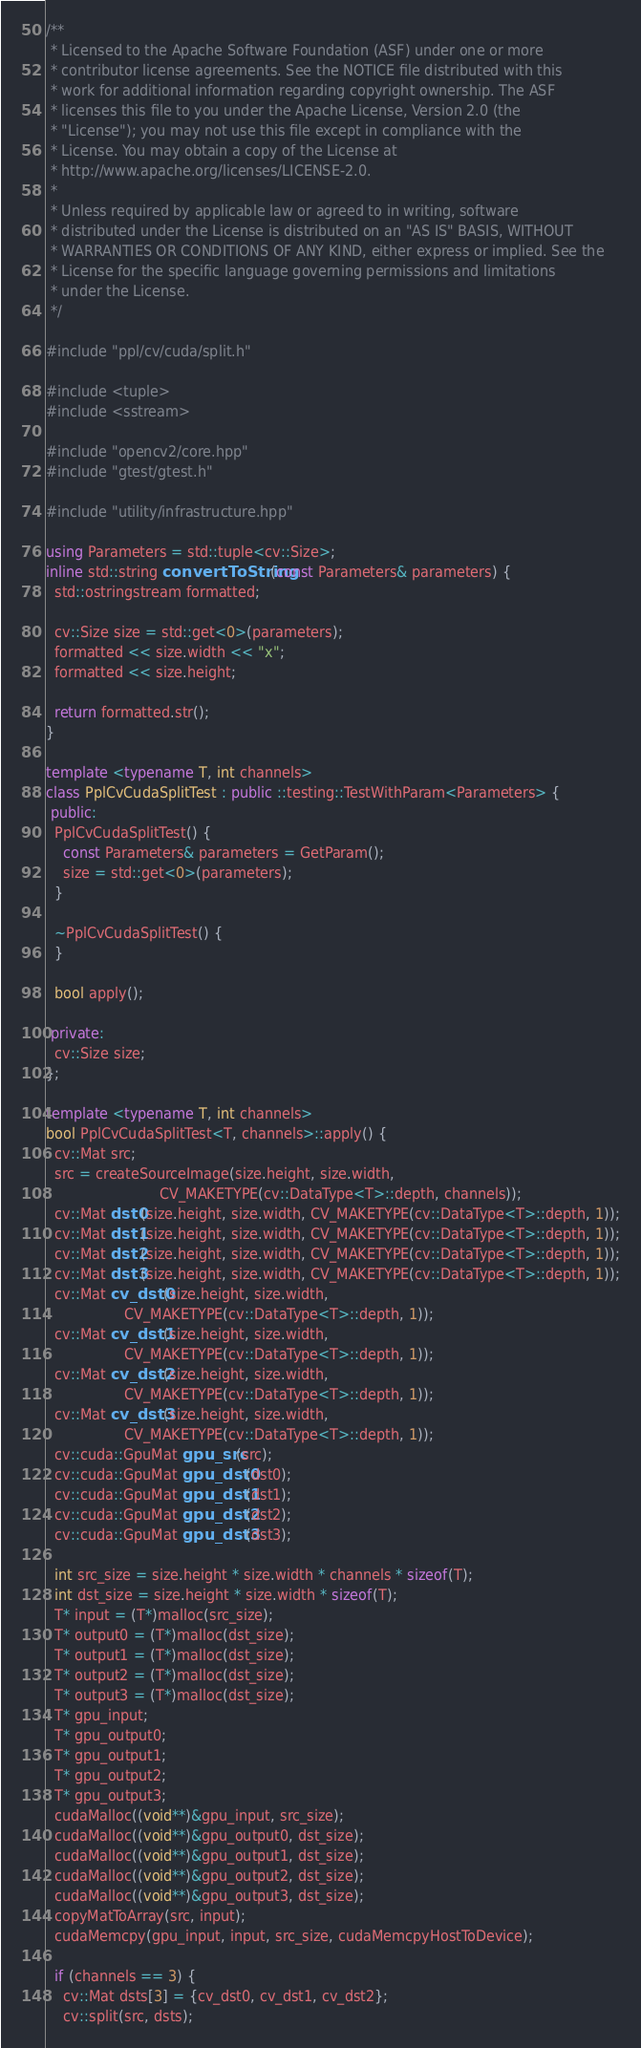<code> <loc_0><loc_0><loc_500><loc_500><_C++_>/**
 * Licensed to the Apache Software Foundation (ASF) under one or more
 * contributor license agreements. See the NOTICE file distributed with this
 * work for additional information regarding copyright ownership. The ASF
 * licenses this file to you under the Apache License, Version 2.0 (the
 * "License"); you may not use this file except in compliance with the
 * License. You may obtain a copy of the License at
 * http://www.apache.org/licenses/LICENSE-2.0.
 *
 * Unless required by applicable law or agreed to in writing, software
 * distributed under the License is distributed on an "AS IS" BASIS, WITHOUT
 * WARRANTIES OR CONDITIONS OF ANY KIND, either express or implied. See the
 * License for the specific language governing permissions and limitations
 * under the License.
 */

#include "ppl/cv/cuda/split.h"

#include <tuple>
#include <sstream>

#include "opencv2/core.hpp"
#include "gtest/gtest.h"

#include "utility/infrastructure.hpp"

using Parameters = std::tuple<cv::Size>;
inline std::string convertToString(const Parameters& parameters) {
  std::ostringstream formatted;

  cv::Size size = std::get<0>(parameters);
  formatted << size.width << "x";
  formatted << size.height;

  return formatted.str();
}

template <typename T, int channels>
class PplCvCudaSplitTest : public ::testing::TestWithParam<Parameters> {
 public:
  PplCvCudaSplitTest() {
    const Parameters& parameters = GetParam();
    size = std::get<0>(parameters);
  }

  ~PplCvCudaSplitTest() {
  }

  bool apply();

 private:
  cv::Size size;
};

template <typename T, int channels>
bool PplCvCudaSplitTest<T, channels>::apply() {
  cv::Mat src;
  src = createSourceImage(size.height, size.width,
                          CV_MAKETYPE(cv::DataType<T>::depth, channels));
  cv::Mat dst0(size.height, size.width, CV_MAKETYPE(cv::DataType<T>::depth, 1));
  cv::Mat dst1(size.height, size.width, CV_MAKETYPE(cv::DataType<T>::depth, 1));
  cv::Mat dst2(size.height, size.width, CV_MAKETYPE(cv::DataType<T>::depth, 1));
  cv::Mat dst3(size.height, size.width, CV_MAKETYPE(cv::DataType<T>::depth, 1));
  cv::Mat cv_dst0(size.height, size.width,
                  CV_MAKETYPE(cv::DataType<T>::depth, 1));
  cv::Mat cv_dst1(size.height, size.width,
                  CV_MAKETYPE(cv::DataType<T>::depth, 1));
  cv::Mat cv_dst2(size.height, size.width,
                  CV_MAKETYPE(cv::DataType<T>::depth, 1));
  cv::Mat cv_dst3(size.height, size.width,
                  CV_MAKETYPE(cv::DataType<T>::depth, 1));
  cv::cuda::GpuMat gpu_src(src);
  cv::cuda::GpuMat gpu_dst0(dst0);
  cv::cuda::GpuMat gpu_dst1(dst1);
  cv::cuda::GpuMat gpu_dst2(dst2);
  cv::cuda::GpuMat gpu_dst3(dst3);

  int src_size = size.height * size.width * channels * sizeof(T);
  int dst_size = size.height * size.width * sizeof(T);
  T* input = (T*)malloc(src_size);
  T* output0 = (T*)malloc(dst_size);
  T* output1 = (T*)malloc(dst_size);
  T* output2 = (T*)malloc(dst_size);
  T* output3 = (T*)malloc(dst_size);
  T* gpu_input;
  T* gpu_output0;
  T* gpu_output1;
  T* gpu_output2;
  T* gpu_output3;
  cudaMalloc((void**)&gpu_input, src_size);
  cudaMalloc((void**)&gpu_output0, dst_size);
  cudaMalloc((void**)&gpu_output1, dst_size);
  cudaMalloc((void**)&gpu_output2, dst_size);
  cudaMalloc((void**)&gpu_output3, dst_size);
  copyMatToArray(src, input);
  cudaMemcpy(gpu_input, input, src_size, cudaMemcpyHostToDevice);

  if (channels == 3) {
    cv::Mat dsts[3] = {cv_dst0, cv_dst1, cv_dst2};
    cv::split(src, dsts);</code> 